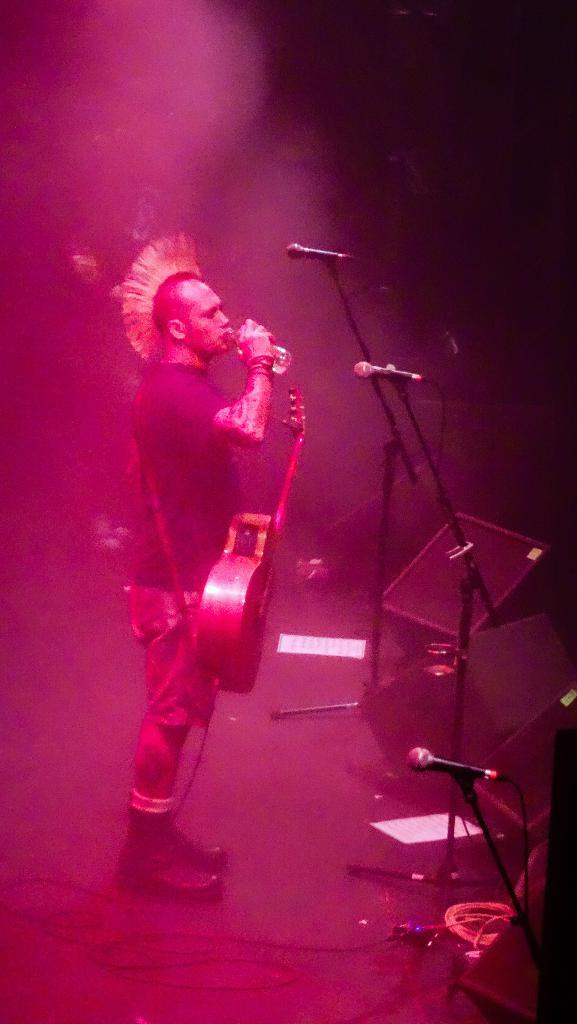What is the person in the image holding? The person is holding a water bottle and a guitar. What is in front of the person? There are 3 microphones in front of the person. What can be seen on the floor in the image? There are wires and papers on the floor. How is the person illuminated in the image? Pink light is falling on the person. What type of net can be seen catching a bear in the image? There is no net or bear present in the image. What color is the ink used to write on the papers on the floor? There is no indication of ink color on the papers in the image, as the color is not mentioned in the provided facts. 